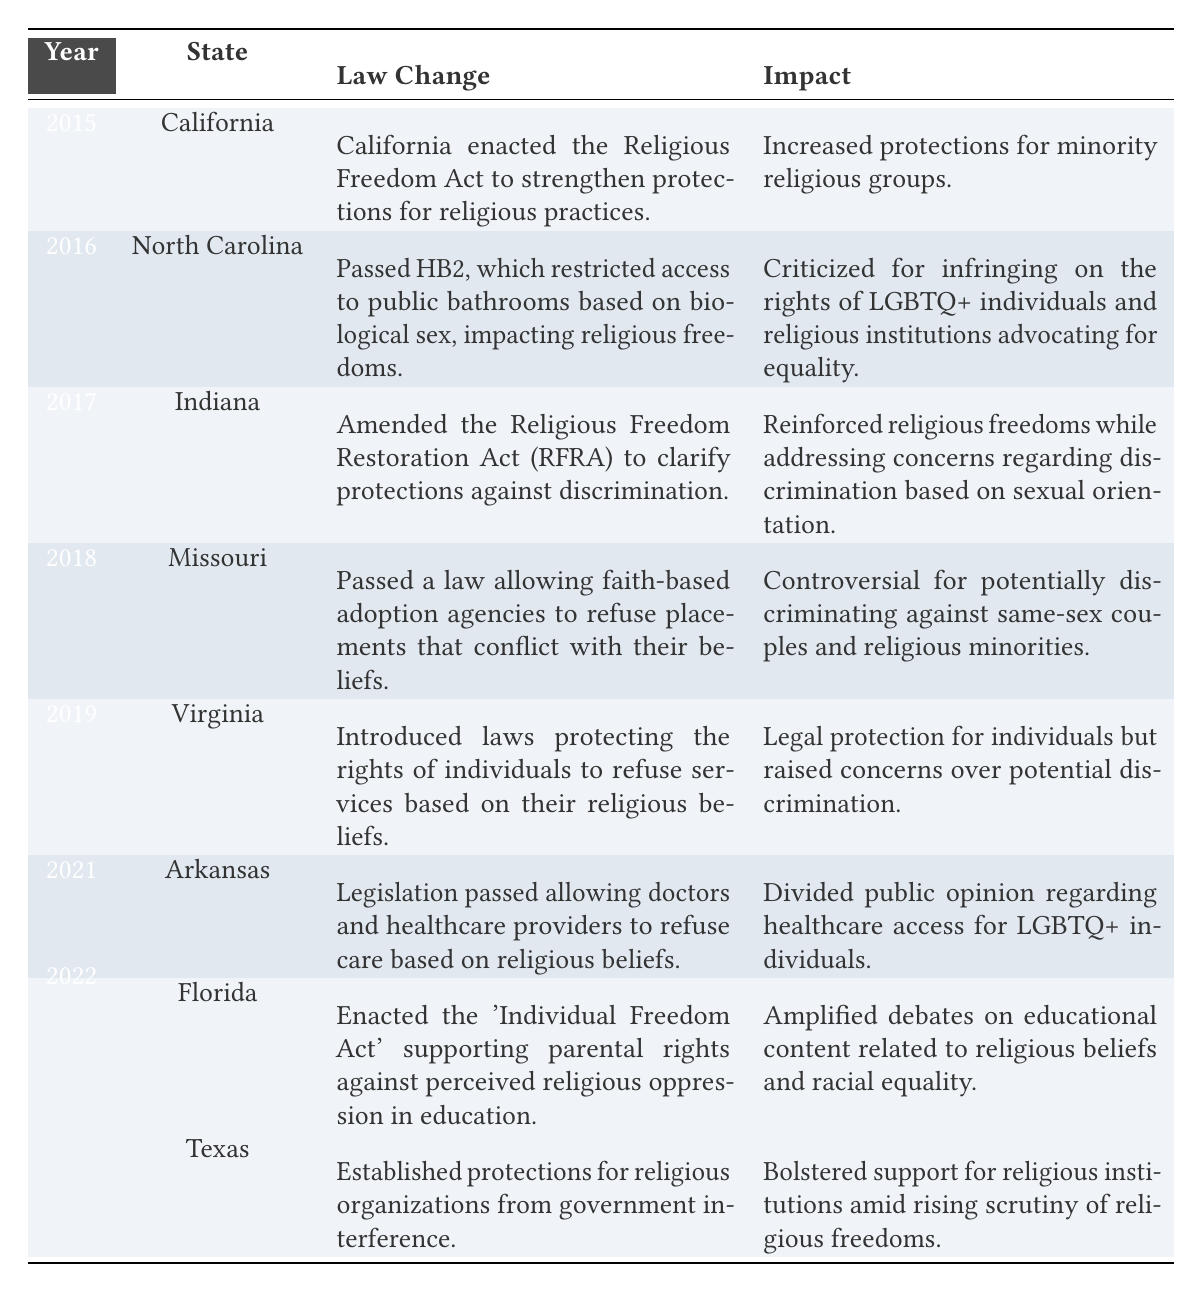What year did California enact the Religious Freedom Act? The table specifies that California enacted the Religious Freedom Act in the year 2015.
Answer: 2015 Which state passed a law in 2016 that restricted bathroom access based on biological sex? The table indicates that North Carolina passed HB2 in 2016, which restricted access to public bathrooms based on biological sex.
Answer: North Carolina How many states changed their laws regarding religious freedoms between 2015 and 2022? The table shows a total of 8 entries (or states) that changed their laws regarding religious freedoms from 2015 to 2022.
Answer: 8 Did Missouri's law in 2018 support or restrict religious freedoms? The table reveals that Missouri passed a law allowing faith-based adoption agencies to refuse placements that conflict with their beliefs, which is seen as controversial and potentially discriminatory. This implies a restriction for certain groups, but could be viewed as supporting the rights of religious organizations. Thus, it is a complex answer, leaning towards a restriction towards some communities.
Answer: Yes (with complexity) Which two states established protections for religious institutions in 2022? The table lists that both Florida and Texas established protections for religious institutions in 2022. Florida's law was the 'Individual Freedom Act,' while Texas established protections from government interference.
Answer: Florida and Texas What is the impact of the law change in Arkansas in 2021? The impact listed for Arkansas's law change in 2021 is that it divided public opinion regarding healthcare access for LGBTQ+ individuals based on religious beliefs.
Answer: Divided public opinion on healthcare access for LGBTQ+ individuals Which state's law raised concerns over potential discrimination due to the right to refuse services based on religious beliefs? According to the table, Virginia's law introduced in 2019 raised concerns over potential discrimination as it allowed individuals to refuse services based on their religious beliefs.
Answer: Virginia How many changes in laws explicitly mentioned potential discrimination against LGBTQ+ individuals? By examining the table, there are three instances: North Carolina in 2016 (regarding HB2), Missouri in 2018, and Arkansas in 2021. Thus a total of 3 changes mention potential discrimination against LGBTQ+ individuals.
Answer: 3 Did any state laws passed from 2015 to 2022 strengthen protections for minority religious groups? The table indicates that California's Religious Freedom Act in 2015 strengthened protections for minority religious groups. Therefore, the answer is yes.
Answer: Yes 